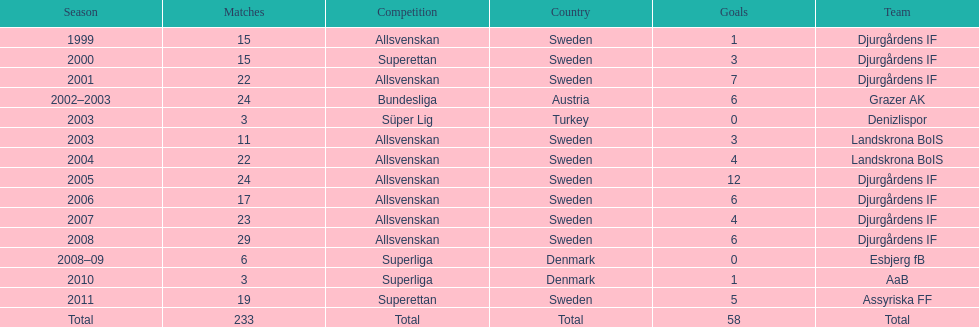Which nation does team djurgårdens if not originate from? Sweden. 